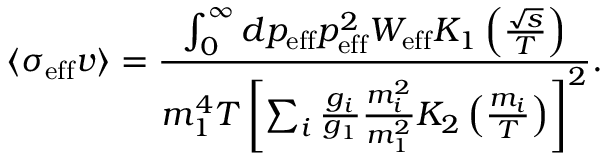Convert formula to latex. <formula><loc_0><loc_0><loc_500><loc_500>\langle \sigma _ { e f f } v \rangle = \frac { \int _ { 0 } ^ { \infty } d p _ { e f f } p _ { e f f } ^ { 2 } W _ { e f f } K _ { 1 } \left ( \frac { \sqrt { s } } { T } \right ) } { m _ { 1 } ^ { 4 } T \left [ \sum _ { i } \frac { g _ { i } } { g _ { 1 } } \frac { m _ { i } ^ { 2 } } { m _ { 1 } ^ { 2 } } K _ { 2 } \left ( \frac { m _ { i } } { T } \right ) \right ] ^ { 2 } } .</formula> 